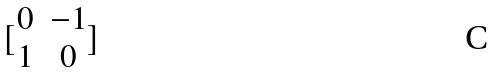Convert formula to latex. <formula><loc_0><loc_0><loc_500><loc_500>[ \begin{matrix} 0 & - 1 \\ 1 & 0 \end{matrix} ]</formula> 